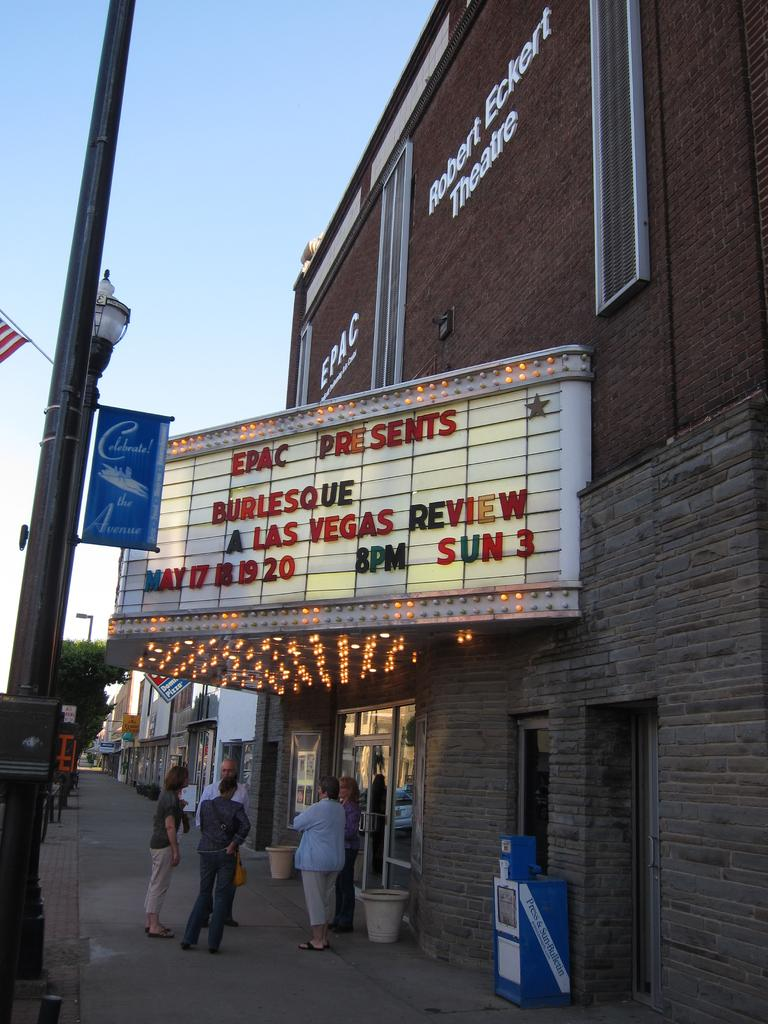What type of structures can be seen in the image? There are buildings in the image. What type of doors are present in the image? There are glass doors in the image. What type of signage is visible in the image? Banners are present in the image. What type of vertical structures can be seen in the image? Poles and light poles are visible in the image. What type of flat surfaces are present in the image? Boards are present in the image. What type of illumination is visible in the image? Lights are visible in the image. What type of vegetation is present in the image? Trees are in the image. What is the color of the sky in the image? The sky is white and blue in color. What is the price of the boat in the image? There is no boat present in the image, so it is not possible to determine its price. How does the drop of water affect the buildings in the image? There is no mention of a drop of water in the image, so it is not possible to determine its effect on the buildings. 